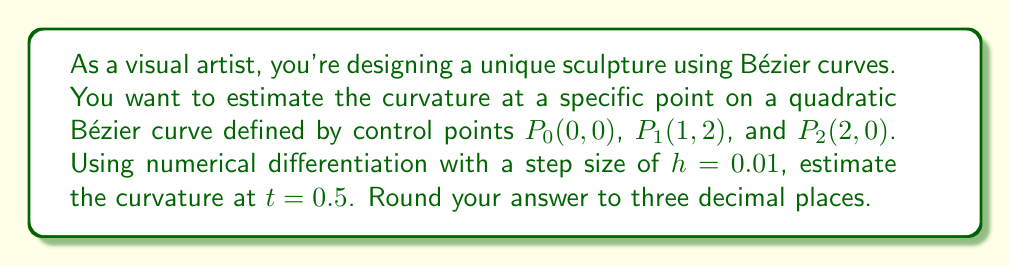Can you answer this question? Let's approach this step-by-step:

1) The quadratic Bézier curve is defined by:
   $$B(t) = (1-t)^2P_0 + 2t(1-t)P_1 + t^2P_2$$

2) At $t=0.5$, we need to calculate $B(0.5)$:
   $$B(0.5) = 0.25(0,0) + 0.5(1,2) + 0.25(2,0) = (1,1)$$

3) To estimate curvature, we need first and second derivatives. We'll use central difference formulas:

   First derivative: $$B'(t) \approx \frac{B(t+h) - B(t-h)}{2h}$$
   Second derivative: $$B''(t) \approx \frac{B(t+h) - 2B(t) + B(t-h)}{h^2}$$

4) Calculate $B(0.49)$ and $B(0.51)$:
   $$B(0.49) = (0.9801,0.9996)$$
   $$B(0.51) = (1.0201,0.9996)$$

5) Estimate $B'(0.5)$:
   $$B'(0.5) \approx \frac{(1.0201,0.9996) - (0.9801,0.9996)}{0.02} = (2,0)$$

6) Estimate $B''(0.5)$:
   $$B''(0.5) \approx \frac{(1.0201,0.9996) - 2(1,1) + (0.9801,0.9996)}{0.01^2} = (0,-4)$$

7) The curvature formula is:
   $$\kappa = \frac{|x'y'' - y'x''|}{(x'^2 + y'^2)^{3/2}}$$

8) Plugging in our values:
   $$\kappa = \frac{|2(-4) - 0(0)|}{(2^2 + 0^2)^{3/2}} = \frac{8}{8} = 1$$

Therefore, the estimated curvature at $t=0.5$ is 1.000 (rounded to three decimal places).
Answer: 1.000 